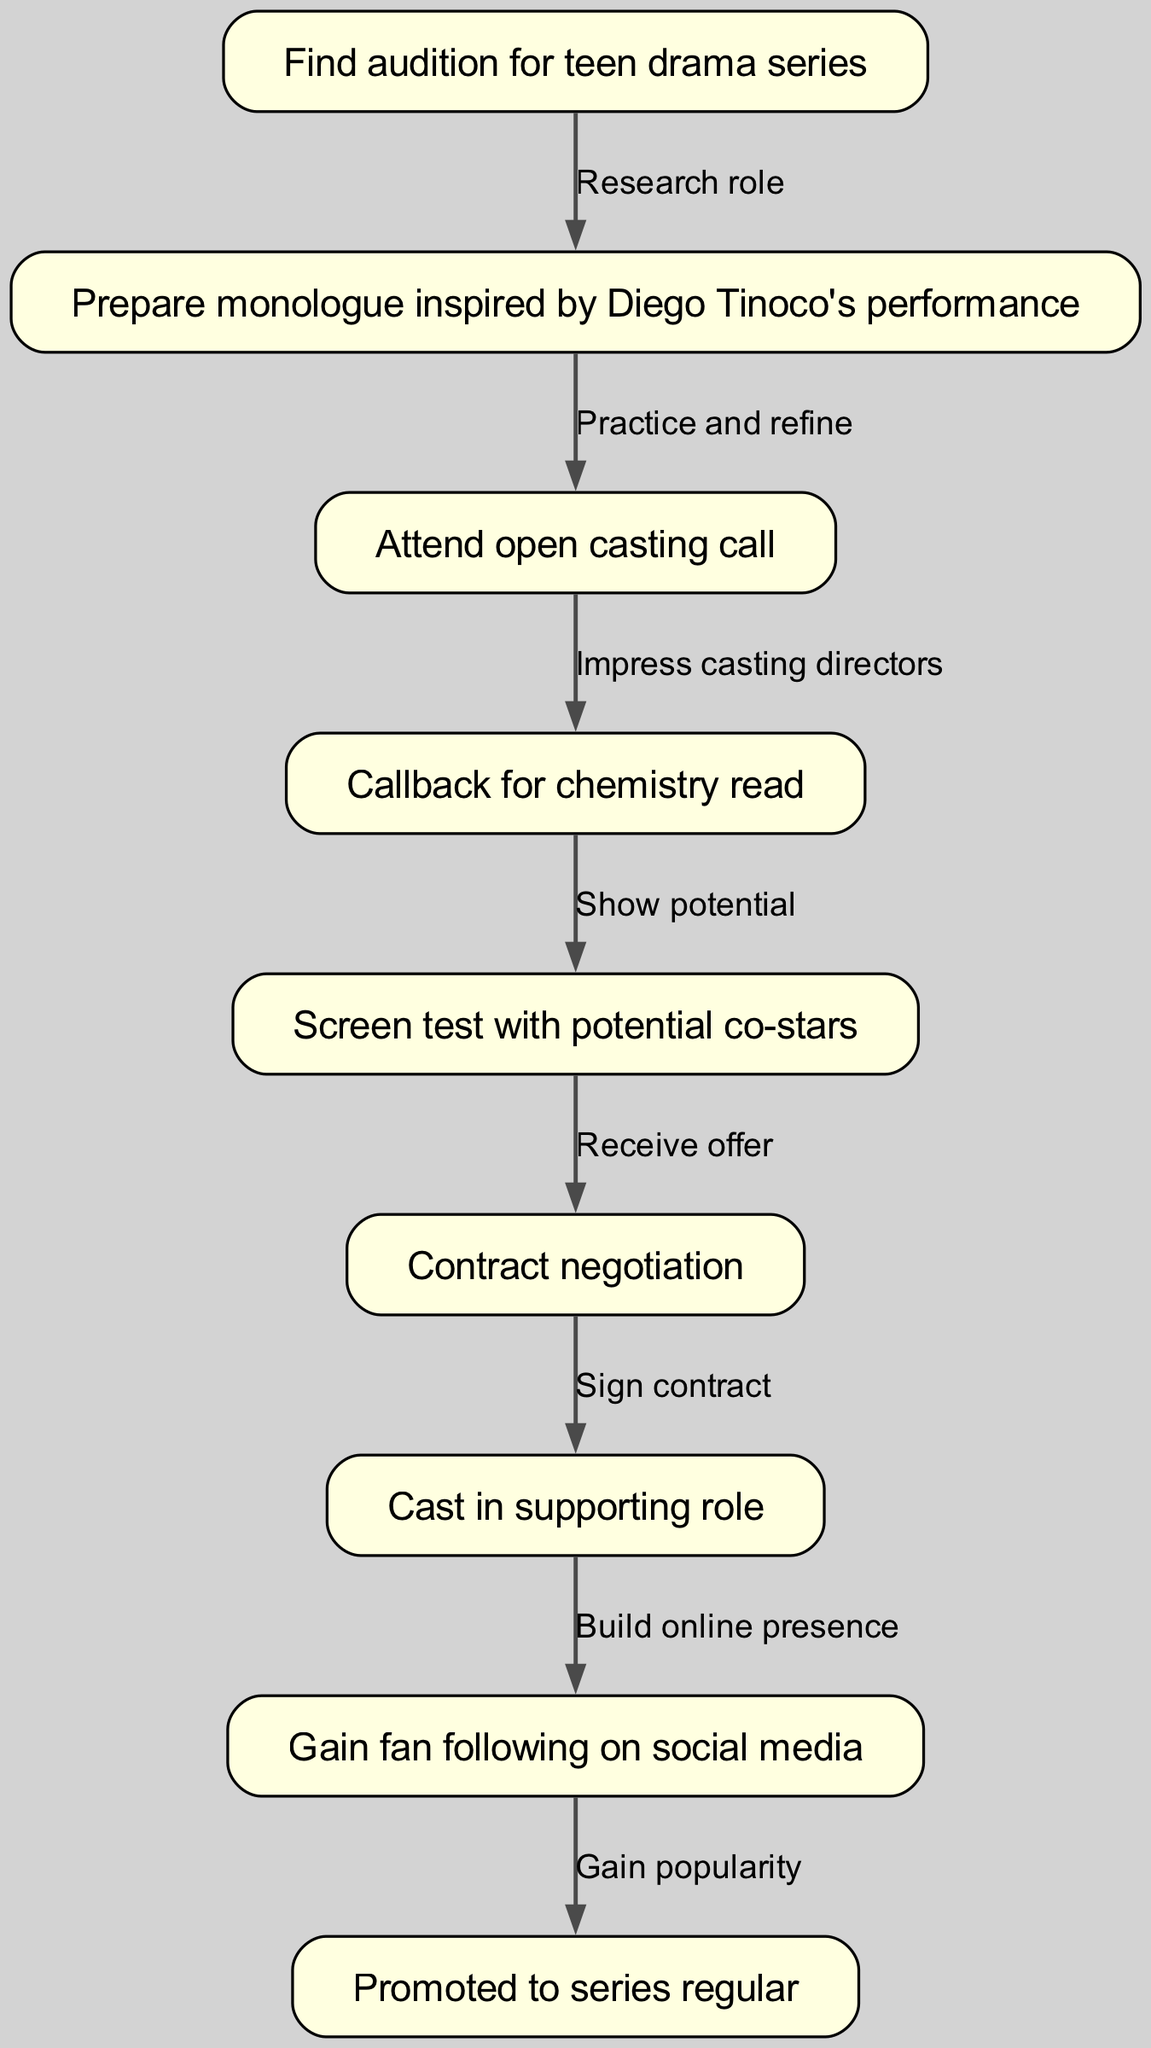What is the first step in the actor's journey? The first step in the journey is represented by the node with ID 1, which states "Find audition for teen drama series."
Answer: Find audition for teen drama series How many nodes are present in the diagram? To determine the number of nodes, we can count the entries in the nodes section of the data. There are 9 nodes listed.
Answer: 9 What is the relationship between the second and third nodes? The second node, "Prepare monologue inspired by Diego Tinoco's performance," leads to the third node, "Attend open casting call," connected by the edge that represents the action "Practice and refine."
Answer: Practice and refine Which node represents the contract negotiation process? The node that indicates the contract negotiation process is identified as node 6, which states "Contract negotiation."
Answer: Contract negotiation What follows after gaining a fan following on social media? The flow from the eighth node "Gain fan following on social media" leads to the ninth node "Promoted to series regular," indicating that gaining a following prepares the actor for promotion.
Answer: Promoted to series regular What is the direct transition before "Screen test with potential co-stars"? The direct transition leading to "Screen test with potential co-stars" is from the node "Callback for chemistry read," represented by the edge "Show potential."
Answer: Show potential After signing the contract, which node does it lead to? After the sixth step "Sign contract," the next node reached is "Cast in supporting role," indicating the progression in the actor's journey post-negotiation.
Answer: Cast in supporting role How many edges are there in the diagram? To find the total number of edges, we count the connections made between nodes in the edges section. There are 8 edges present in the diagram.
Answer: 8 Which node corresponds to building an online presence? The node that corresponds to building an online presence is node 8, denoted as "Gain fan following on social media," emphasizing the importance of social media for an actor's career.
Answer: Gain fan following on social media 